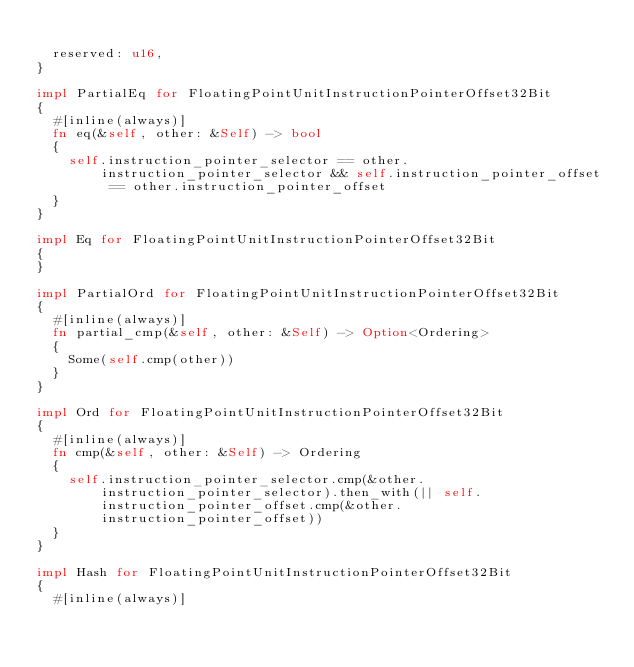<code> <loc_0><loc_0><loc_500><loc_500><_Rust_>
	reserved: u16,
}

impl PartialEq for FloatingPointUnitInstructionPointerOffset32Bit
{
	#[inline(always)]
	fn eq(&self, other: &Self) -> bool
	{
		self.instruction_pointer_selector == other.instruction_pointer_selector && self.instruction_pointer_offset == other.instruction_pointer_offset
	}
}

impl Eq for FloatingPointUnitInstructionPointerOffset32Bit
{
}

impl PartialOrd for FloatingPointUnitInstructionPointerOffset32Bit
{
	#[inline(always)]
	fn partial_cmp(&self, other: &Self) -> Option<Ordering>
	{
		Some(self.cmp(other))
	}
}

impl Ord for FloatingPointUnitInstructionPointerOffset32Bit
{
	#[inline(always)]
	fn cmp(&self, other: &Self) -> Ordering
	{
		self.instruction_pointer_selector.cmp(&other.instruction_pointer_selector).then_with(|| self.instruction_pointer_offset.cmp(&other.instruction_pointer_offset))
	}
}

impl Hash for FloatingPointUnitInstructionPointerOffset32Bit
{
	#[inline(always)]</code> 